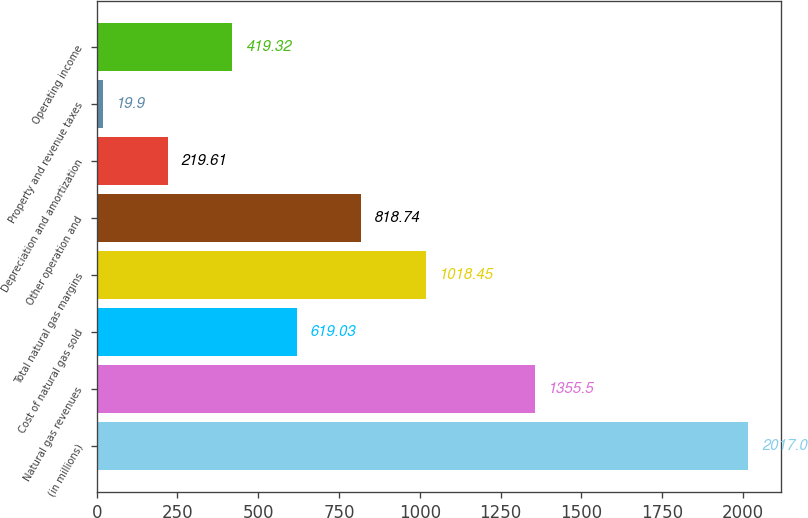Convert chart to OTSL. <chart><loc_0><loc_0><loc_500><loc_500><bar_chart><fcel>(in millions)<fcel>Natural gas revenues<fcel>Cost of natural gas sold<fcel>Total natural gas margins<fcel>Other operation and<fcel>Depreciation and amortization<fcel>Property and revenue taxes<fcel>Operating income<nl><fcel>2017<fcel>1355.5<fcel>619.03<fcel>1018.45<fcel>818.74<fcel>219.61<fcel>19.9<fcel>419.32<nl></chart> 